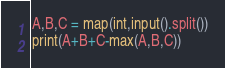Convert code to text. <code><loc_0><loc_0><loc_500><loc_500><_Python_>A,B,C = map(int,input().split())
print(A+B+C-max(A,B,C))</code> 